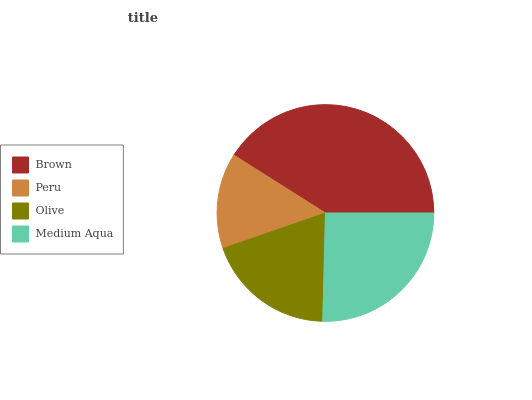Is Peru the minimum?
Answer yes or no. Yes. Is Brown the maximum?
Answer yes or no. Yes. Is Olive the minimum?
Answer yes or no. No. Is Olive the maximum?
Answer yes or no. No. Is Olive greater than Peru?
Answer yes or no. Yes. Is Peru less than Olive?
Answer yes or no. Yes. Is Peru greater than Olive?
Answer yes or no. No. Is Olive less than Peru?
Answer yes or no. No. Is Medium Aqua the high median?
Answer yes or no. Yes. Is Olive the low median?
Answer yes or no. Yes. Is Brown the high median?
Answer yes or no. No. Is Medium Aqua the low median?
Answer yes or no. No. 